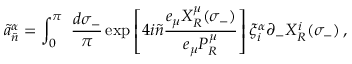<formula> <loc_0><loc_0><loc_500><loc_500>\tilde { a } _ { \tilde { n } } ^ { \alpha } = \int _ { 0 } ^ { \pi } \frac { d \sigma _ { - } } { \pi } \exp \left [ 4 i \tilde { n } \frac { e _ { \mu } X _ { R } ^ { \mu } ( \sigma _ { - } ) } { e _ { \mu } P _ { R } ^ { \mu } } \right ] \xi _ { i } ^ { \alpha } \partial _ { - } X _ { R } ^ { i } ( \sigma _ { - } ) \, ,</formula> 